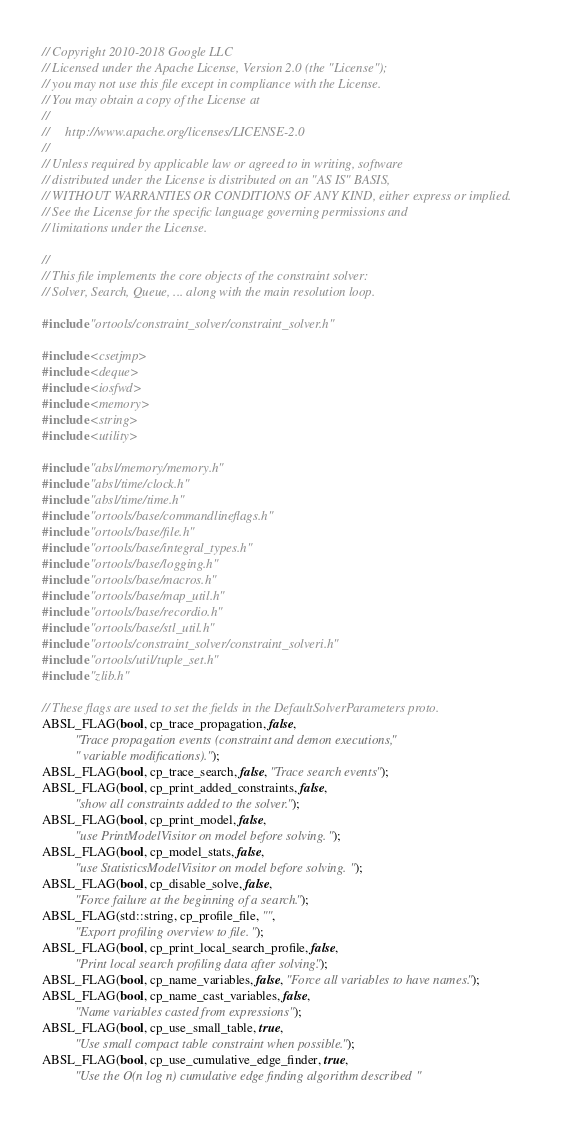Convert code to text. <code><loc_0><loc_0><loc_500><loc_500><_C++_>// Copyright 2010-2018 Google LLC
// Licensed under the Apache License, Version 2.0 (the "License");
// you may not use this file except in compliance with the License.
// You may obtain a copy of the License at
//
//     http://www.apache.org/licenses/LICENSE-2.0
//
// Unless required by applicable law or agreed to in writing, software
// distributed under the License is distributed on an "AS IS" BASIS,
// WITHOUT WARRANTIES OR CONDITIONS OF ANY KIND, either express or implied.
// See the License for the specific language governing permissions and
// limitations under the License.

//
// This file implements the core objects of the constraint solver:
// Solver, Search, Queue, ... along with the main resolution loop.

#include "ortools/constraint_solver/constraint_solver.h"

#include <csetjmp>
#include <deque>
#include <iosfwd>
#include <memory>
#include <string>
#include <utility>

#include "absl/memory/memory.h"
#include "absl/time/clock.h"
#include "absl/time/time.h"
#include "ortools/base/commandlineflags.h"
#include "ortools/base/file.h"
#include "ortools/base/integral_types.h"
#include "ortools/base/logging.h"
#include "ortools/base/macros.h"
#include "ortools/base/map_util.h"
#include "ortools/base/recordio.h"
#include "ortools/base/stl_util.h"
#include "ortools/constraint_solver/constraint_solveri.h"
#include "ortools/util/tuple_set.h"
#include "zlib.h"

// These flags are used to set the fields in the DefaultSolverParameters proto.
ABSL_FLAG(bool, cp_trace_propagation, false,
          "Trace propagation events (constraint and demon executions,"
          " variable modifications).");
ABSL_FLAG(bool, cp_trace_search, false, "Trace search events");
ABSL_FLAG(bool, cp_print_added_constraints, false,
          "show all constraints added to the solver.");
ABSL_FLAG(bool, cp_print_model, false,
          "use PrintModelVisitor on model before solving.");
ABSL_FLAG(bool, cp_model_stats, false,
          "use StatisticsModelVisitor on model before solving.");
ABSL_FLAG(bool, cp_disable_solve, false,
          "Force failure at the beginning of a search.");
ABSL_FLAG(std::string, cp_profile_file, "",
          "Export profiling overview to file.");
ABSL_FLAG(bool, cp_print_local_search_profile, false,
          "Print local search profiling data after solving.");
ABSL_FLAG(bool, cp_name_variables, false, "Force all variables to have names.");
ABSL_FLAG(bool, cp_name_cast_variables, false,
          "Name variables casted from expressions");
ABSL_FLAG(bool, cp_use_small_table, true,
          "Use small compact table constraint when possible.");
ABSL_FLAG(bool, cp_use_cumulative_edge_finder, true,
          "Use the O(n log n) cumulative edge finding algorithm described "</code> 